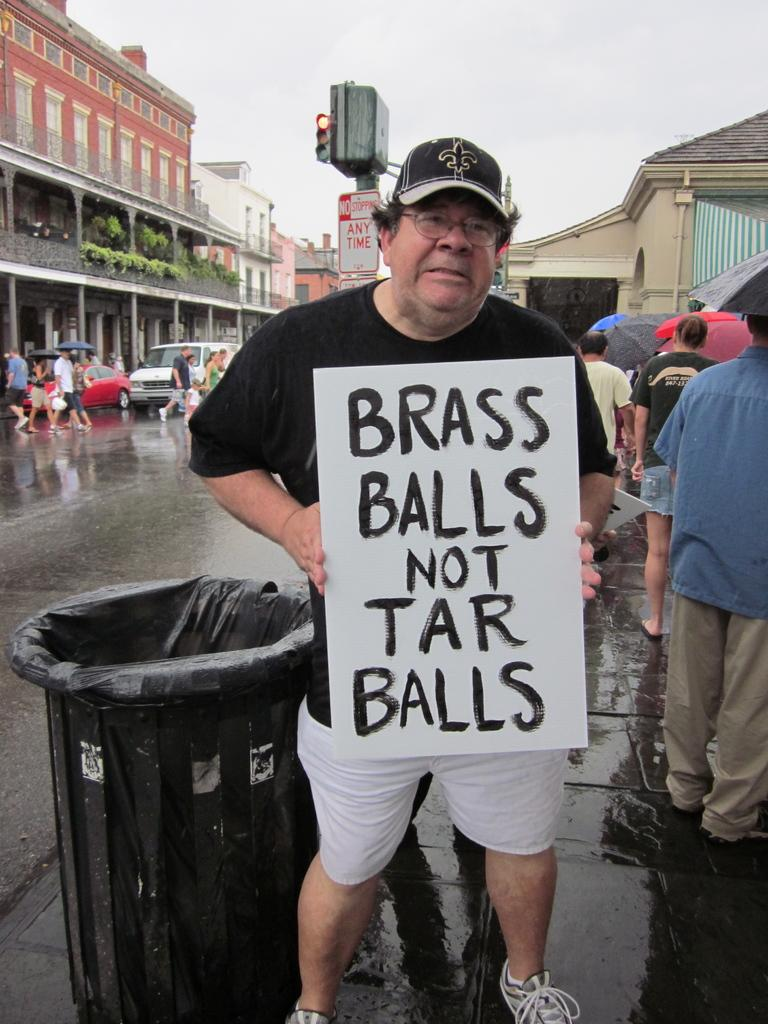<image>
Render a clear and concise summary of the photo. A man wearing a Saints hat is holding up a sign that says "Brass Balls Not Tar Balls". 